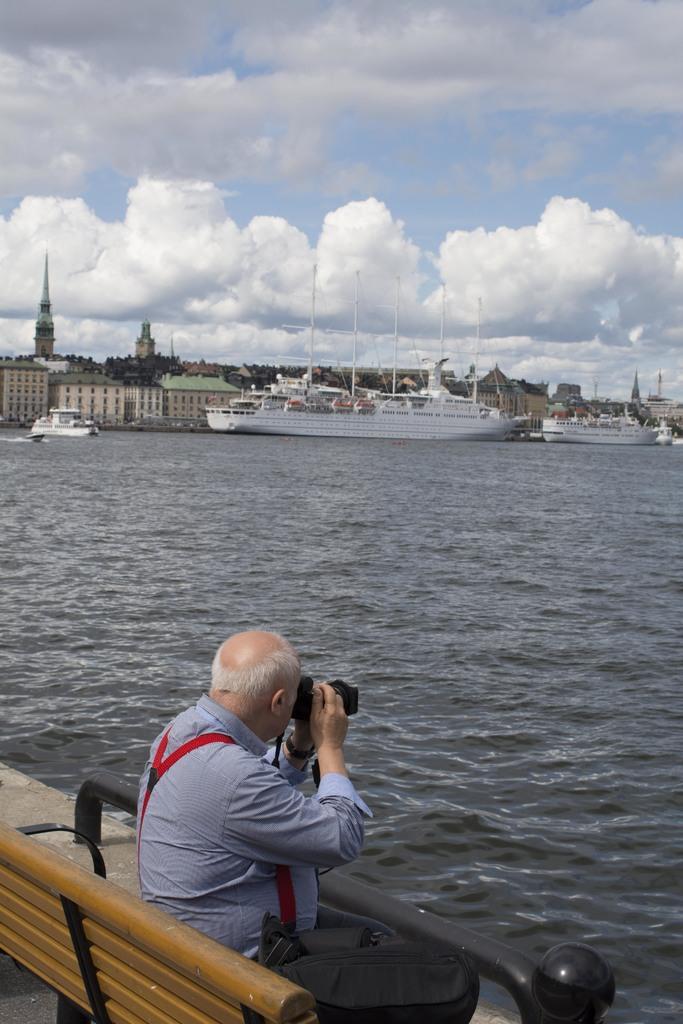Could you give a brief overview of what you see in this image? Here we can see a man sitting on the bench, and holding a camera in his hands, and here is the water, and here are the ships, and at above here is the sky cloudy. 